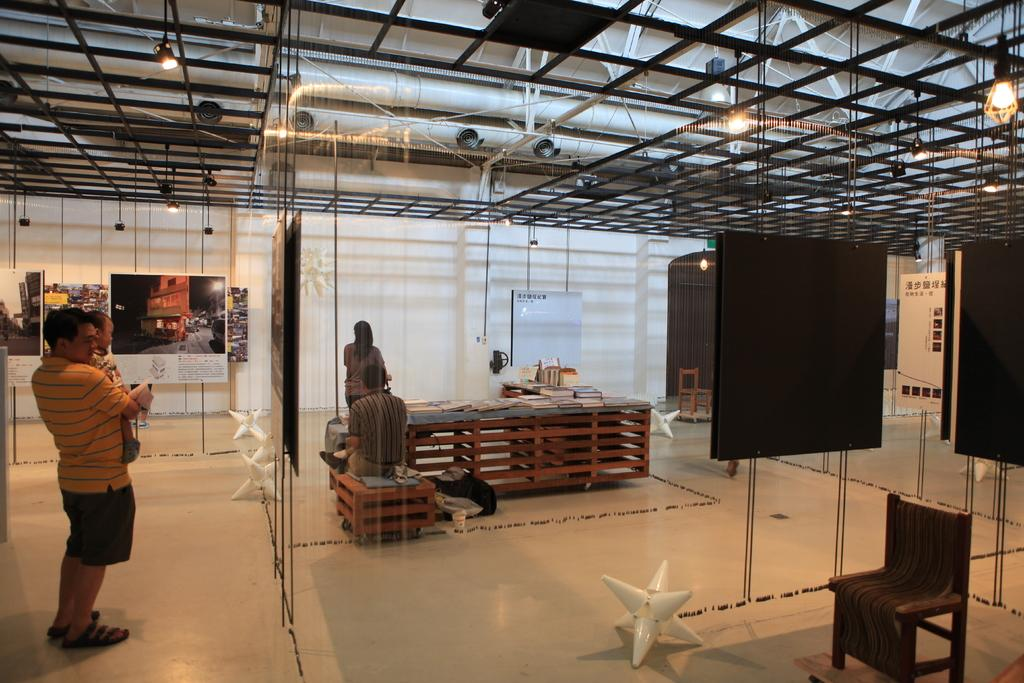What is the main subject of the image? There is a man standing in the image. What is above the man in the image? The man is under an iron ceiling. What is behind the man in the image? There is a table behind the man. What is on the table in the image? There are books on the table. What is in front of the man in the image? There is a screen in front of the man. What type of slope can be seen in the image? There is no slope present in the image. How many eggs are visible on the table in the image? There are no eggs visible on the table in the image; there are only books. 